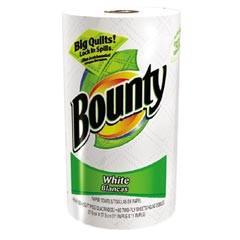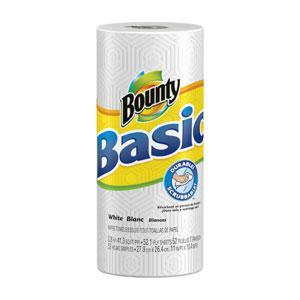The first image is the image on the left, the second image is the image on the right. For the images displayed, is the sentence "The left image contains a multipack of paper towel rolls with a baby's face on the front, and the right image contains packaging with the same color scheme as the left." factually correct? Answer yes or no. No. The first image is the image on the left, the second image is the image on the right. Assess this claim about the two images: "There is a child with a messy face.". Correct or not? Answer yes or no. No. 